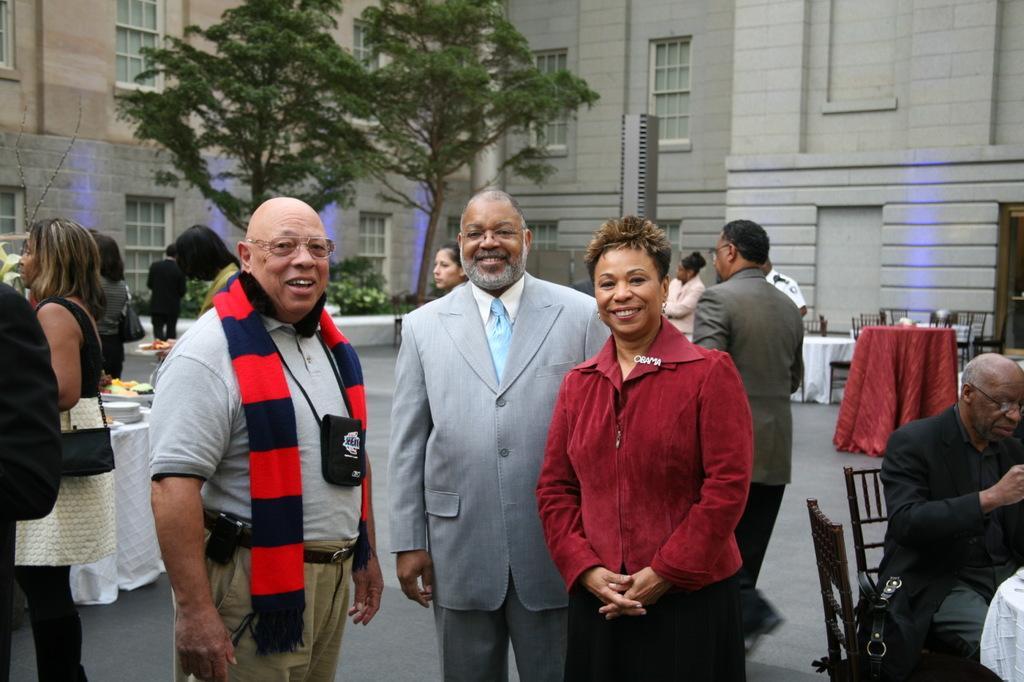Can you describe this image briefly? In this image we can see few people standing on the ground, a person sitting on the chair, there are few chairs and tables covered with clothes and there are few objects on the table, in the background there are trees, plants and buildings. 